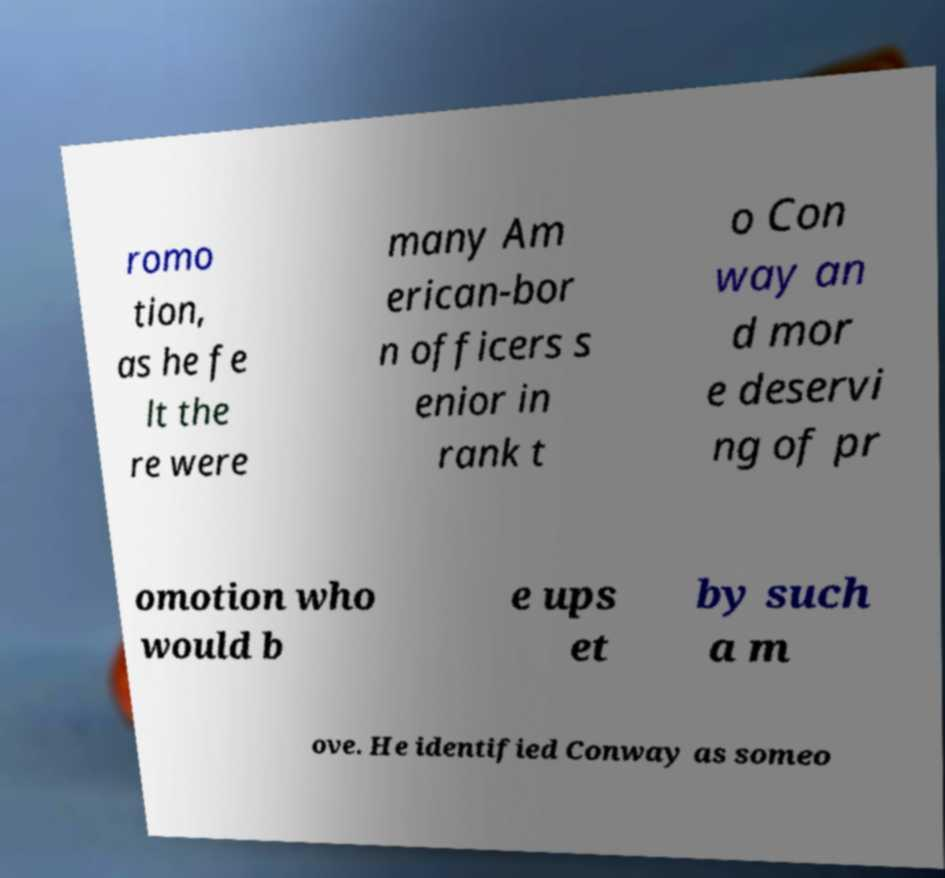Please read and relay the text visible in this image. What does it say? romo tion, as he fe lt the re were many Am erican-bor n officers s enior in rank t o Con way an d mor e deservi ng of pr omotion who would b e ups et by such a m ove. He identified Conway as someo 